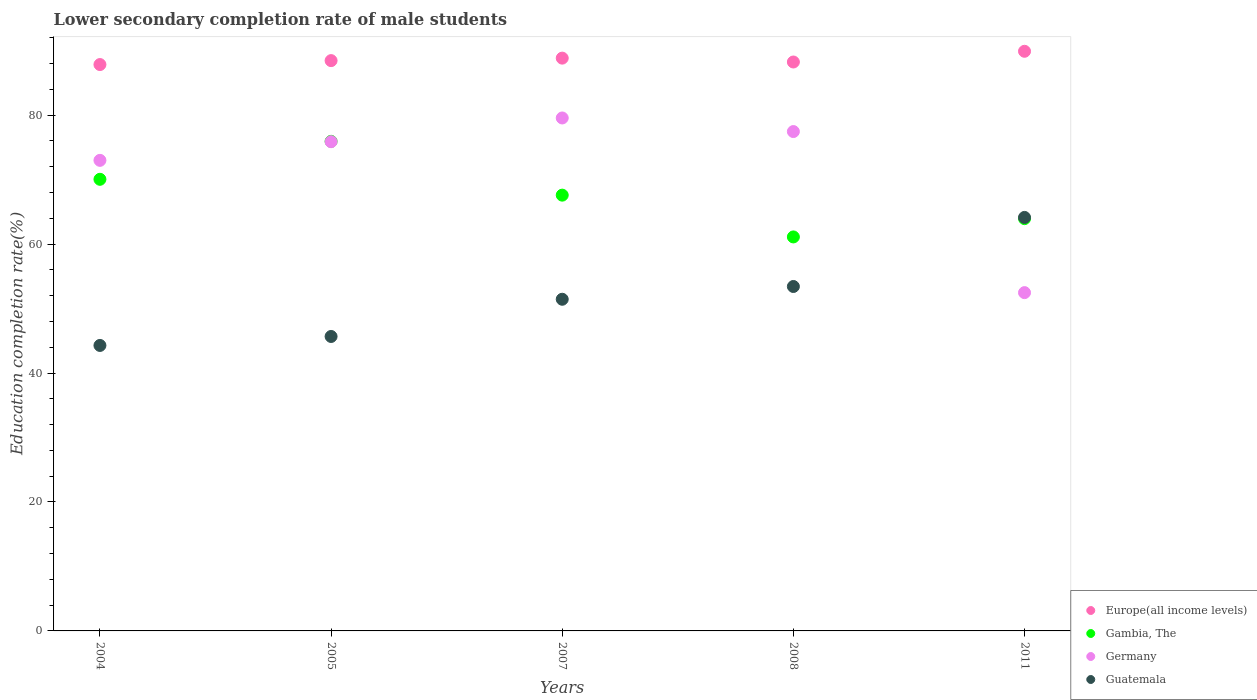Is the number of dotlines equal to the number of legend labels?
Your answer should be very brief. Yes. What is the lower secondary completion rate of male students in Germany in 2007?
Your response must be concise. 79.57. Across all years, what is the maximum lower secondary completion rate of male students in Guatemala?
Make the answer very short. 64.15. Across all years, what is the minimum lower secondary completion rate of male students in Guatemala?
Your answer should be very brief. 44.28. In which year was the lower secondary completion rate of male students in Gambia, The maximum?
Make the answer very short. 2005. In which year was the lower secondary completion rate of male students in Europe(all income levels) minimum?
Offer a very short reply. 2004. What is the total lower secondary completion rate of male students in Europe(all income levels) in the graph?
Ensure brevity in your answer.  443.35. What is the difference between the lower secondary completion rate of male students in Germany in 2004 and that in 2007?
Make the answer very short. -6.57. What is the difference between the lower secondary completion rate of male students in Europe(all income levels) in 2011 and the lower secondary completion rate of male students in Guatemala in 2007?
Make the answer very short. 38.47. What is the average lower secondary completion rate of male students in Gambia, The per year?
Ensure brevity in your answer.  67.74. In the year 2008, what is the difference between the lower secondary completion rate of male students in Gambia, The and lower secondary completion rate of male students in Europe(all income levels)?
Provide a short and direct response. -27.14. What is the ratio of the lower secondary completion rate of male students in Gambia, The in 2005 to that in 2007?
Make the answer very short. 1.12. What is the difference between the highest and the second highest lower secondary completion rate of male students in Gambia, The?
Ensure brevity in your answer.  5.89. What is the difference between the highest and the lowest lower secondary completion rate of male students in Guatemala?
Your response must be concise. 19.86. In how many years, is the lower secondary completion rate of male students in Guatemala greater than the average lower secondary completion rate of male students in Guatemala taken over all years?
Provide a short and direct response. 2. Is it the case that in every year, the sum of the lower secondary completion rate of male students in Guatemala and lower secondary completion rate of male students in Germany  is greater than the sum of lower secondary completion rate of male students in Europe(all income levels) and lower secondary completion rate of male students in Gambia, The?
Keep it short and to the point. No. Is the lower secondary completion rate of male students in Gambia, The strictly greater than the lower secondary completion rate of male students in Germany over the years?
Keep it short and to the point. No. What is the difference between two consecutive major ticks on the Y-axis?
Your answer should be compact. 20. Does the graph contain any zero values?
Your response must be concise. No. Does the graph contain grids?
Ensure brevity in your answer.  No. What is the title of the graph?
Provide a short and direct response. Lower secondary completion rate of male students. What is the label or title of the X-axis?
Give a very brief answer. Years. What is the label or title of the Y-axis?
Provide a short and direct response. Education completion rate(%). What is the Education completion rate(%) in Europe(all income levels) in 2004?
Offer a very short reply. 87.86. What is the Education completion rate(%) in Gambia, The in 2004?
Provide a short and direct response. 70.06. What is the Education completion rate(%) in Germany in 2004?
Give a very brief answer. 73. What is the Education completion rate(%) in Guatemala in 2004?
Keep it short and to the point. 44.28. What is the Education completion rate(%) in Europe(all income levels) in 2005?
Provide a succinct answer. 88.47. What is the Education completion rate(%) in Gambia, The in 2005?
Provide a short and direct response. 75.95. What is the Education completion rate(%) in Germany in 2005?
Make the answer very short. 75.89. What is the Education completion rate(%) in Guatemala in 2005?
Your response must be concise. 45.68. What is the Education completion rate(%) of Europe(all income levels) in 2007?
Your answer should be compact. 88.85. What is the Education completion rate(%) in Gambia, The in 2007?
Provide a short and direct response. 67.6. What is the Education completion rate(%) in Germany in 2007?
Make the answer very short. 79.57. What is the Education completion rate(%) of Guatemala in 2007?
Offer a terse response. 51.45. What is the Education completion rate(%) in Europe(all income levels) in 2008?
Provide a short and direct response. 88.25. What is the Education completion rate(%) in Gambia, The in 2008?
Keep it short and to the point. 61.12. What is the Education completion rate(%) of Germany in 2008?
Your response must be concise. 77.46. What is the Education completion rate(%) of Guatemala in 2008?
Provide a short and direct response. 53.43. What is the Education completion rate(%) of Europe(all income levels) in 2011?
Ensure brevity in your answer.  89.92. What is the Education completion rate(%) of Gambia, The in 2011?
Your response must be concise. 63.95. What is the Education completion rate(%) in Germany in 2011?
Your response must be concise. 52.48. What is the Education completion rate(%) of Guatemala in 2011?
Give a very brief answer. 64.15. Across all years, what is the maximum Education completion rate(%) in Europe(all income levels)?
Your response must be concise. 89.92. Across all years, what is the maximum Education completion rate(%) in Gambia, The?
Provide a succinct answer. 75.95. Across all years, what is the maximum Education completion rate(%) in Germany?
Offer a very short reply. 79.57. Across all years, what is the maximum Education completion rate(%) of Guatemala?
Ensure brevity in your answer.  64.15. Across all years, what is the minimum Education completion rate(%) in Europe(all income levels)?
Offer a very short reply. 87.86. Across all years, what is the minimum Education completion rate(%) in Gambia, The?
Provide a short and direct response. 61.12. Across all years, what is the minimum Education completion rate(%) of Germany?
Your answer should be very brief. 52.48. Across all years, what is the minimum Education completion rate(%) of Guatemala?
Make the answer very short. 44.28. What is the total Education completion rate(%) in Europe(all income levels) in the graph?
Make the answer very short. 443.35. What is the total Education completion rate(%) in Gambia, The in the graph?
Offer a terse response. 338.68. What is the total Education completion rate(%) of Germany in the graph?
Your answer should be compact. 358.4. What is the total Education completion rate(%) in Guatemala in the graph?
Offer a very short reply. 258.99. What is the difference between the Education completion rate(%) of Europe(all income levels) in 2004 and that in 2005?
Provide a succinct answer. -0.61. What is the difference between the Education completion rate(%) in Gambia, The in 2004 and that in 2005?
Your answer should be compact. -5.89. What is the difference between the Education completion rate(%) of Germany in 2004 and that in 2005?
Make the answer very short. -2.89. What is the difference between the Education completion rate(%) in Guatemala in 2004 and that in 2005?
Give a very brief answer. -1.39. What is the difference between the Education completion rate(%) of Europe(all income levels) in 2004 and that in 2007?
Provide a short and direct response. -1. What is the difference between the Education completion rate(%) in Gambia, The in 2004 and that in 2007?
Keep it short and to the point. 2.46. What is the difference between the Education completion rate(%) of Germany in 2004 and that in 2007?
Offer a very short reply. -6.57. What is the difference between the Education completion rate(%) of Guatemala in 2004 and that in 2007?
Your answer should be very brief. -7.17. What is the difference between the Education completion rate(%) of Europe(all income levels) in 2004 and that in 2008?
Your answer should be very brief. -0.4. What is the difference between the Education completion rate(%) in Gambia, The in 2004 and that in 2008?
Offer a terse response. 8.94. What is the difference between the Education completion rate(%) in Germany in 2004 and that in 2008?
Provide a succinct answer. -4.47. What is the difference between the Education completion rate(%) of Guatemala in 2004 and that in 2008?
Give a very brief answer. -9.15. What is the difference between the Education completion rate(%) of Europe(all income levels) in 2004 and that in 2011?
Offer a terse response. -2.06. What is the difference between the Education completion rate(%) in Gambia, The in 2004 and that in 2011?
Offer a very short reply. 6.1. What is the difference between the Education completion rate(%) in Germany in 2004 and that in 2011?
Ensure brevity in your answer.  20.52. What is the difference between the Education completion rate(%) in Guatemala in 2004 and that in 2011?
Make the answer very short. -19.86. What is the difference between the Education completion rate(%) in Europe(all income levels) in 2005 and that in 2007?
Offer a very short reply. -0.39. What is the difference between the Education completion rate(%) of Gambia, The in 2005 and that in 2007?
Your answer should be compact. 8.35. What is the difference between the Education completion rate(%) of Germany in 2005 and that in 2007?
Offer a terse response. -3.68. What is the difference between the Education completion rate(%) in Guatemala in 2005 and that in 2007?
Your response must be concise. -5.77. What is the difference between the Education completion rate(%) of Europe(all income levels) in 2005 and that in 2008?
Provide a succinct answer. 0.21. What is the difference between the Education completion rate(%) in Gambia, The in 2005 and that in 2008?
Provide a short and direct response. 14.83. What is the difference between the Education completion rate(%) in Germany in 2005 and that in 2008?
Your response must be concise. -1.57. What is the difference between the Education completion rate(%) in Guatemala in 2005 and that in 2008?
Provide a succinct answer. -7.75. What is the difference between the Education completion rate(%) in Europe(all income levels) in 2005 and that in 2011?
Provide a succinct answer. -1.45. What is the difference between the Education completion rate(%) in Gambia, The in 2005 and that in 2011?
Give a very brief answer. 11.99. What is the difference between the Education completion rate(%) in Germany in 2005 and that in 2011?
Offer a terse response. 23.41. What is the difference between the Education completion rate(%) in Guatemala in 2005 and that in 2011?
Provide a short and direct response. -18.47. What is the difference between the Education completion rate(%) in Europe(all income levels) in 2007 and that in 2008?
Offer a terse response. 0.6. What is the difference between the Education completion rate(%) of Gambia, The in 2007 and that in 2008?
Give a very brief answer. 6.48. What is the difference between the Education completion rate(%) in Germany in 2007 and that in 2008?
Offer a terse response. 2.11. What is the difference between the Education completion rate(%) of Guatemala in 2007 and that in 2008?
Give a very brief answer. -1.98. What is the difference between the Education completion rate(%) in Europe(all income levels) in 2007 and that in 2011?
Ensure brevity in your answer.  -1.06. What is the difference between the Education completion rate(%) of Gambia, The in 2007 and that in 2011?
Your answer should be compact. 3.65. What is the difference between the Education completion rate(%) of Germany in 2007 and that in 2011?
Make the answer very short. 27.1. What is the difference between the Education completion rate(%) of Guatemala in 2007 and that in 2011?
Offer a terse response. -12.7. What is the difference between the Education completion rate(%) of Europe(all income levels) in 2008 and that in 2011?
Your answer should be very brief. -1.66. What is the difference between the Education completion rate(%) in Gambia, The in 2008 and that in 2011?
Make the answer very short. -2.84. What is the difference between the Education completion rate(%) in Germany in 2008 and that in 2011?
Your answer should be compact. 24.99. What is the difference between the Education completion rate(%) in Guatemala in 2008 and that in 2011?
Your answer should be compact. -10.72. What is the difference between the Education completion rate(%) of Europe(all income levels) in 2004 and the Education completion rate(%) of Gambia, The in 2005?
Offer a terse response. 11.91. What is the difference between the Education completion rate(%) of Europe(all income levels) in 2004 and the Education completion rate(%) of Germany in 2005?
Ensure brevity in your answer.  11.97. What is the difference between the Education completion rate(%) of Europe(all income levels) in 2004 and the Education completion rate(%) of Guatemala in 2005?
Offer a terse response. 42.18. What is the difference between the Education completion rate(%) of Gambia, The in 2004 and the Education completion rate(%) of Germany in 2005?
Provide a succinct answer. -5.83. What is the difference between the Education completion rate(%) in Gambia, The in 2004 and the Education completion rate(%) in Guatemala in 2005?
Give a very brief answer. 24.38. What is the difference between the Education completion rate(%) of Germany in 2004 and the Education completion rate(%) of Guatemala in 2005?
Make the answer very short. 27.32. What is the difference between the Education completion rate(%) in Europe(all income levels) in 2004 and the Education completion rate(%) in Gambia, The in 2007?
Your answer should be very brief. 20.26. What is the difference between the Education completion rate(%) of Europe(all income levels) in 2004 and the Education completion rate(%) of Germany in 2007?
Your answer should be very brief. 8.29. What is the difference between the Education completion rate(%) in Europe(all income levels) in 2004 and the Education completion rate(%) in Guatemala in 2007?
Keep it short and to the point. 36.41. What is the difference between the Education completion rate(%) in Gambia, The in 2004 and the Education completion rate(%) in Germany in 2007?
Offer a terse response. -9.51. What is the difference between the Education completion rate(%) in Gambia, The in 2004 and the Education completion rate(%) in Guatemala in 2007?
Your response must be concise. 18.61. What is the difference between the Education completion rate(%) of Germany in 2004 and the Education completion rate(%) of Guatemala in 2007?
Your answer should be very brief. 21.55. What is the difference between the Education completion rate(%) in Europe(all income levels) in 2004 and the Education completion rate(%) in Gambia, The in 2008?
Your answer should be compact. 26.74. What is the difference between the Education completion rate(%) in Europe(all income levels) in 2004 and the Education completion rate(%) in Germany in 2008?
Give a very brief answer. 10.39. What is the difference between the Education completion rate(%) in Europe(all income levels) in 2004 and the Education completion rate(%) in Guatemala in 2008?
Give a very brief answer. 34.43. What is the difference between the Education completion rate(%) of Gambia, The in 2004 and the Education completion rate(%) of Germany in 2008?
Your response must be concise. -7.41. What is the difference between the Education completion rate(%) of Gambia, The in 2004 and the Education completion rate(%) of Guatemala in 2008?
Your answer should be very brief. 16.63. What is the difference between the Education completion rate(%) in Germany in 2004 and the Education completion rate(%) in Guatemala in 2008?
Make the answer very short. 19.57. What is the difference between the Education completion rate(%) of Europe(all income levels) in 2004 and the Education completion rate(%) of Gambia, The in 2011?
Offer a terse response. 23.9. What is the difference between the Education completion rate(%) of Europe(all income levels) in 2004 and the Education completion rate(%) of Germany in 2011?
Give a very brief answer. 35.38. What is the difference between the Education completion rate(%) in Europe(all income levels) in 2004 and the Education completion rate(%) in Guatemala in 2011?
Your answer should be compact. 23.71. What is the difference between the Education completion rate(%) in Gambia, The in 2004 and the Education completion rate(%) in Germany in 2011?
Ensure brevity in your answer.  17.58. What is the difference between the Education completion rate(%) in Gambia, The in 2004 and the Education completion rate(%) in Guatemala in 2011?
Your answer should be compact. 5.91. What is the difference between the Education completion rate(%) of Germany in 2004 and the Education completion rate(%) of Guatemala in 2011?
Ensure brevity in your answer.  8.85. What is the difference between the Education completion rate(%) of Europe(all income levels) in 2005 and the Education completion rate(%) of Gambia, The in 2007?
Ensure brevity in your answer.  20.87. What is the difference between the Education completion rate(%) in Europe(all income levels) in 2005 and the Education completion rate(%) in Germany in 2007?
Keep it short and to the point. 8.9. What is the difference between the Education completion rate(%) of Europe(all income levels) in 2005 and the Education completion rate(%) of Guatemala in 2007?
Make the answer very short. 37.02. What is the difference between the Education completion rate(%) of Gambia, The in 2005 and the Education completion rate(%) of Germany in 2007?
Your response must be concise. -3.62. What is the difference between the Education completion rate(%) of Gambia, The in 2005 and the Education completion rate(%) of Guatemala in 2007?
Your answer should be very brief. 24.5. What is the difference between the Education completion rate(%) of Germany in 2005 and the Education completion rate(%) of Guatemala in 2007?
Offer a very short reply. 24.44. What is the difference between the Education completion rate(%) in Europe(all income levels) in 2005 and the Education completion rate(%) in Gambia, The in 2008?
Ensure brevity in your answer.  27.35. What is the difference between the Education completion rate(%) in Europe(all income levels) in 2005 and the Education completion rate(%) in Germany in 2008?
Ensure brevity in your answer.  11. What is the difference between the Education completion rate(%) of Europe(all income levels) in 2005 and the Education completion rate(%) of Guatemala in 2008?
Make the answer very short. 35.04. What is the difference between the Education completion rate(%) of Gambia, The in 2005 and the Education completion rate(%) of Germany in 2008?
Keep it short and to the point. -1.52. What is the difference between the Education completion rate(%) of Gambia, The in 2005 and the Education completion rate(%) of Guatemala in 2008?
Your answer should be compact. 22.52. What is the difference between the Education completion rate(%) in Germany in 2005 and the Education completion rate(%) in Guatemala in 2008?
Offer a very short reply. 22.46. What is the difference between the Education completion rate(%) of Europe(all income levels) in 2005 and the Education completion rate(%) of Gambia, The in 2011?
Make the answer very short. 24.51. What is the difference between the Education completion rate(%) in Europe(all income levels) in 2005 and the Education completion rate(%) in Germany in 2011?
Your answer should be compact. 35.99. What is the difference between the Education completion rate(%) of Europe(all income levels) in 2005 and the Education completion rate(%) of Guatemala in 2011?
Give a very brief answer. 24.32. What is the difference between the Education completion rate(%) in Gambia, The in 2005 and the Education completion rate(%) in Germany in 2011?
Offer a very short reply. 23.47. What is the difference between the Education completion rate(%) of Gambia, The in 2005 and the Education completion rate(%) of Guatemala in 2011?
Your answer should be very brief. 11.8. What is the difference between the Education completion rate(%) in Germany in 2005 and the Education completion rate(%) in Guatemala in 2011?
Provide a short and direct response. 11.75. What is the difference between the Education completion rate(%) of Europe(all income levels) in 2007 and the Education completion rate(%) of Gambia, The in 2008?
Ensure brevity in your answer.  27.74. What is the difference between the Education completion rate(%) of Europe(all income levels) in 2007 and the Education completion rate(%) of Germany in 2008?
Give a very brief answer. 11.39. What is the difference between the Education completion rate(%) of Europe(all income levels) in 2007 and the Education completion rate(%) of Guatemala in 2008?
Make the answer very short. 35.42. What is the difference between the Education completion rate(%) of Gambia, The in 2007 and the Education completion rate(%) of Germany in 2008?
Your answer should be compact. -9.86. What is the difference between the Education completion rate(%) of Gambia, The in 2007 and the Education completion rate(%) of Guatemala in 2008?
Ensure brevity in your answer.  14.17. What is the difference between the Education completion rate(%) in Germany in 2007 and the Education completion rate(%) in Guatemala in 2008?
Provide a short and direct response. 26.14. What is the difference between the Education completion rate(%) of Europe(all income levels) in 2007 and the Education completion rate(%) of Gambia, The in 2011?
Keep it short and to the point. 24.9. What is the difference between the Education completion rate(%) of Europe(all income levels) in 2007 and the Education completion rate(%) of Germany in 2011?
Your response must be concise. 36.38. What is the difference between the Education completion rate(%) in Europe(all income levels) in 2007 and the Education completion rate(%) in Guatemala in 2011?
Your answer should be compact. 24.71. What is the difference between the Education completion rate(%) of Gambia, The in 2007 and the Education completion rate(%) of Germany in 2011?
Your answer should be very brief. 15.12. What is the difference between the Education completion rate(%) in Gambia, The in 2007 and the Education completion rate(%) in Guatemala in 2011?
Offer a terse response. 3.45. What is the difference between the Education completion rate(%) in Germany in 2007 and the Education completion rate(%) in Guatemala in 2011?
Keep it short and to the point. 15.43. What is the difference between the Education completion rate(%) of Europe(all income levels) in 2008 and the Education completion rate(%) of Gambia, The in 2011?
Offer a terse response. 24.3. What is the difference between the Education completion rate(%) in Europe(all income levels) in 2008 and the Education completion rate(%) in Germany in 2011?
Provide a short and direct response. 35.78. What is the difference between the Education completion rate(%) in Europe(all income levels) in 2008 and the Education completion rate(%) in Guatemala in 2011?
Ensure brevity in your answer.  24.11. What is the difference between the Education completion rate(%) in Gambia, The in 2008 and the Education completion rate(%) in Germany in 2011?
Ensure brevity in your answer.  8.64. What is the difference between the Education completion rate(%) in Gambia, The in 2008 and the Education completion rate(%) in Guatemala in 2011?
Your answer should be very brief. -3.03. What is the difference between the Education completion rate(%) of Germany in 2008 and the Education completion rate(%) of Guatemala in 2011?
Ensure brevity in your answer.  13.32. What is the average Education completion rate(%) in Europe(all income levels) per year?
Keep it short and to the point. 88.67. What is the average Education completion rate(%) in Gambia, The per year?
Your answer should be compact. 67.74. What is the average Education completion rate(%) of Germany per year?
Make the answer very short. 71.68. What is the average Education completion rate(%) of Guatemala per year?
Offer a very short reply. 51.8. In the year 2004, what is the difference between the Education completion rate(%) of Europe(all income levels) and Education completion rate(%) of Gambia, The?
Offer a very short reply. 17.8. In the year 2004, what is the difference between the Education completion rate(%) in Europe(all income levels) and Education completion rate(%) in Germany?
Ensure brevity in your answer.  14.86. In the year 2004, what is the difference between the Education completion rate(%) of Europe(all income levels) and Education completion rate(%) of Guatemala?
Your answer should be very brief. 43.57. In the year 2004, what is the difference between the Education completion rate(%) of Gambia, The and Education completion rate(%) of Germany?
Your answer should be very brief. -2.94. In the year 2004, what is the difference between the Education completion rate(%) in Gambia, The and Education completion rate(%) in Guatemala?
Provide a succinct answer. 25.77. In the year 2004, what is the difference between the Education completion rate(%) in Germany and Education completion rate(%) in Guatemala?
Offer a terse response. 28.71. In the year 2005, what is the difference between the Education completion rate(%) of Europe(all income levels) and Education completion rate(%) of Gambia, The?
Your response must be concise. 12.52. In the year 2005, what is the difference between the Education completion rate(%) of Europe(all income levels) and Education completion rate(%) of Germany?
Offer a very short reply. 12.58. In the year 2005, what is the difference between the Education completion rate(%) of Europe(all income levels) and Education completion rate(%) of Guatemala?
Keep it short and to the point. 42.79. In the year 2005, what is the difference between the Education completion rate(%) of Gambia, The and Education completion rate(%) of Germany?
Provide a succinct answer. 0.06. In the year 2005, what is the difference between the Education completion rate(%) in Gambia, The and Education completion rate(%) in Guatemala?
Offer a very short reply. 30.27. In the year 2005, what is the difference between the Education completion rate(%) in Germany and Education completion rate(%) in Guatemala?
Your answer should be very brief. 30.22. In the year 2007, what is the difference between the Education completion rate(%) in Europe(all income levels) and Education completion rate(%) in Gambia, The?
Provide a succinct answer. 21.25. In the year 2007, what is the difference between the Education completion rate(%) in Europe(all income levels) and Education completion rate(%) in Germany?
Give a very brief answer. 9.28. In the year 2007, what is the difference between the Education completion rate(%) of Europe(all income levels) and Education completion rate(%) of Guatemala?
Your answer should be very brief. 37.4. In the year 2007, what is the difference between the Education completion rate(%) in Gambia, The and Education completion rate(%) in Germany?
Give a very brief answer. -11.97. In the year 2007, what is the difference between the Education completion rate(%) of Gambia, The and Education completion rate(%) of Guatemala?
Your answer should be compact. 16.15. In the year 2007, what is the difference between the Education completion rate(%) of Germany and Education completion rate(%) of Guatemala?
Provide a succinct answer. 28.12. In the year 2008, what is the difference between the Education completion rate(%) in Europe(all income levels) and Education completion rate(%) in Gambia, The?
Provide a short and direct response. 27.14. In the year 2008, what is the difference between the Education completion rate(%) of Europe(all income levels) and Education completion rate(%) of Germany?
Offer a very short reply. 10.79. In the year 2008, what is the difference between the Education completion rate(%) of Europe(all income levels) and Education completion rate(%) of Guatemala?
Ensure brevity in your answer.  34.82. In the year 2008, what is the difference between the Education completion rate(%) in Gambia, The and Education completion rate(%) in Germany?
Your answer should be compact. -16.35. In the year 2008, what is the difference between the Education completion rate(%) in Gambia, The and Education completion rate(%) in Guatemala?
Your answer should be very brief. 7.69. In the year 2008, what is the difference between the Education completion rate(%) in Germany and Education completion rate(%) in Guatemala?
Keep it short and to the point. 24.03. In the year 2011, what is the difference between the Education completion rate(%) of Europe(all income levels) and Education completion rate(%) of Gambia, The?
Provide a short and direct response. 25.96. In the year 2011, what is the difference between the Education completion rate(%) of Europe(all income levels) and Education completion rate(%) of Germany?
Keep it short and to the point. 37.44. In the year 2011, what is the difference between the Education completion rate(%) of Europe(all income levels) and Education completion rate(%) of Guatemala?
Your answer should be compact. 25.77. In the year 2011, what is the difference between the Education completion rate(%) in Gambia, The and Education completion rate(%) in Germany?
Offer a terse response. 11.48. In the year 2011, what is the difference between the Education completion rate(%) in Gambia, The and Education completion rate(%) in Guatemala?
Offer a very short reply. -0.19. In the year 2011, what is the difference between the Education completion rate(%) of Germany and Education completion rate(%) of Guatemala?
Keep it short and to the point. -11.67. What is the ratio of the Education completion rate(%) of Europe(all income levels) in 2004 to that in 2005?
Provide a short and direct response. 0.99. What is the ratio of the Education completion rate(%) of Gambia, The in 2004 to that in 2005?
Ensure brevity in your answer.  0.92. What is the ratio of the Education completion rate(%) of Germany in 2004 to that in 2005?
Your answer should be very brief. 0.96. What is the ratio of the Education completion rate(%) of Guatemala in 2004 to that in 2005?
Make the answer very short. 0.97. What is the ratio of the Education completion rate(%) in Europe(all income levels) in 2004 to that in 2007?
Provide a succinct answer. 0.99. What is the ratio of the Education completion rate(%) of Gambia, The in 2004 to that in 2007?
Provide a succinct answer. 1.04. What is the ratio of the Education completion rate(%) of Germany in 2004 to that in 2007?
Provide a short and direct response. 0.92. What is the ratio of the Education completion rate(%) of Guatemala in 2004 to that in 2007?
Offer a terse response. 0.86. What is the ratio of the Education completion rate(%) in Gambia, The in 2004 to that in 2008?
Offer a terse response. 1.15. What is the ratio of the Education completion rate(%) in Germany in 2004 to that in 2008?
Keep it short and to the point. 0.94. What is the ratio of the Education completion rate(%) of Guatemala in 2004 to that in 2008?
Provide a succinct answer. 0.83. What is the ratio of the Education completion rate(%) in Europe(all income levels) in 2004 to that in 2011?
Ensure brevity in your answer.  0.98. What is the ratio of the Education completion rate(%) of Gambia, The in 2004 to that in 2011?
Your answer should be compact. 1.1. What is the ratio of the Education completion rate(%) in Germany in 2004 to that in 2011?
Ensure brevity in your answer.  1.39. What is the ratio of the Education completion rate(%) of Guatemala in 2004 to that in 2011?
Provide a succinct answer. 0.69. What is the ratio of the Education completion rate(%) of Europe(all income levels) in 2005 to that in 2007?
Ensure brevity in your answer.  1. What is the ratio of the Education completion rate(%) of Gambia, The in 2005 to that in 2007?
Provide a short and direct response. 1.12. What is the ratio of the Education completion rate(%) of Germany in 2005 to that in 2007?
Provide a short and direct response. 0.95. What is the ratio of the Education completion rate(%) in Guatemala in 2005 to that in 2007?
Provide a succinct answer. 0.89. What is the ratio of the Education completion rate(%) in Gambia, The in 2005 to that in 2008?
Provide a succinct answer. 1.24. What is the ratio of the Education completion rate(%) in Germany in 2005 to that in 2008?
Your answer should be very brief. 0.98. What is the ratio of the Education completion rate(%) in Guatemala in 2005 to that in 2008?
Provide a succinct answer. 0.85. What is the ratio of the Education completion rate(%) of Europe(all income levels) in 2005 to that in 2011?
Make the answer very short. 0.98. What is the ratio of the Education completion rate(%) of Gambia, The in 2005 to that in 2011?
Your answer should be compact. 1.19. What is the ratio of the Education completion rate(%) of Germany in 2005 to that in 2011?
Make the answer very short. 1.45. What is the ratio of the Education completion rate(%) of Guatemala in 2005 to that in 2011?
Give a very brief answer. 0.71. What is the ratio of the Education completion rate(%) in Europe(all income levels) in 2007 to that in 2008?
Your answer should be very brief. 1.01. What is the ratio of the Education completion rate(%) in Gambia, The in 2007 to that in 2008?
Give a very brief answer. 1.11. What is the ratio of the Education completion rate(%) of Germany in 2007 to that in 2008?
Offer a very short reply. 1.03. What is the ratio of the Education completion rate(%) of Guatemala in 2007 to that in 2008?
Offer a terse response. 0.96. What is the ratio of the Education completion rate(%) of Gambia, The in 2007 to that in 2011?
Your answer should be compact. 1.06. What is the ratio of the Education completion rate(%) in Germany in 2007 to that in 2011?
Make the answer very short. 1.52. What is the ratio of the Education completion rate(%) in Guatemala in 2007 to that in 2011?
Provide a short and direct response. 0.8. What is the ratio of the Education completion rate(%) of Europe(all income levels) in 2008 to that in 2011?
Provide a short and direct response. 0.98. What is the ratio of the Education completion rate(%) in Gambia, The in 2008 to that in 2011?
Your response must be concise. 0.96. What is the ratio of the Education completion rate(%) of Germany in 2008 to that in 2011?
Provide a short and direct response. 1.48. What is the ratio of the Education completion rate(%) of Guatemala in 2008 to that in 2011?
Keep it short and to the point. 0.83. What is the difference between the highest and the second highest Education completion rate(%) in Europe(all income levels)?
Offer a very short reply. 1.06. What is the difference between the highest and the second highest Education completion rate(%) in Gambia, The?
Your answer should be very brief. 5.89. What is the difference between the highest and the second highest Education completion rate(%) in Germany?
Make the answer very short. 2.11. What is the difference between the highest and the second highest Education completion rate(%) of Guatemala?
Offer a very short reply. 10.72. What is the difference between the highest and the lowest Education completion rate(%) in Europe(all income levels)?
Ensure brevity in your answer.  2.06. What is the difference between the highest and the lowest Education completion rate(%) in Gambia, The?
Give a very brief answer. 14.83. What is the difference between the highest and the lowest Education completion rate(%) in Germany?
Ensure brevity in your answer.  27.1. What is the difference between the highest and the lowest Education completion rate(%) of Guatemala?
Your response must be concise. 19.86. 